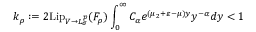<formula> <loc_0><loc_0><loc_500><loc_500>k _ { \rho } \colon = 2 L i p _ { V \to L _ { \sigma } ^ { p } } ( F _ { \rho } ) \int _ { 0 } ^ { \infty } C _ { \alpha } e ^ { ( \mu _ { 2 } + \varepsilon - \mu ) y } y ^ { - \alpha } d y < 1</formula> 